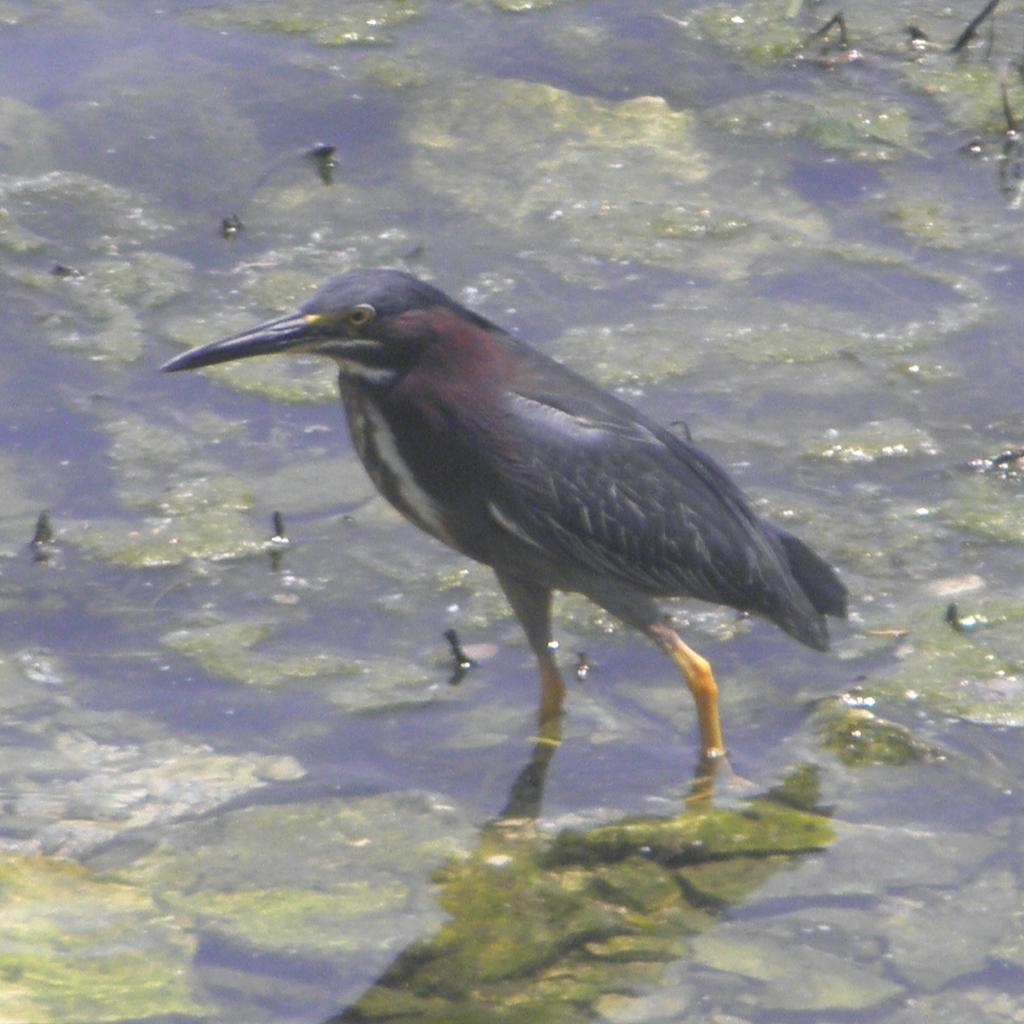What type of animal can be seen in the image? There is a bird in the water in the image. Can you describe the bird's location in the image? The bird is in the water in the image. What flavor of lunch is the bird eating in the image? There is no indication in the image that the bird is eating lunch, nor is there any information about the flavor of the lunch. 